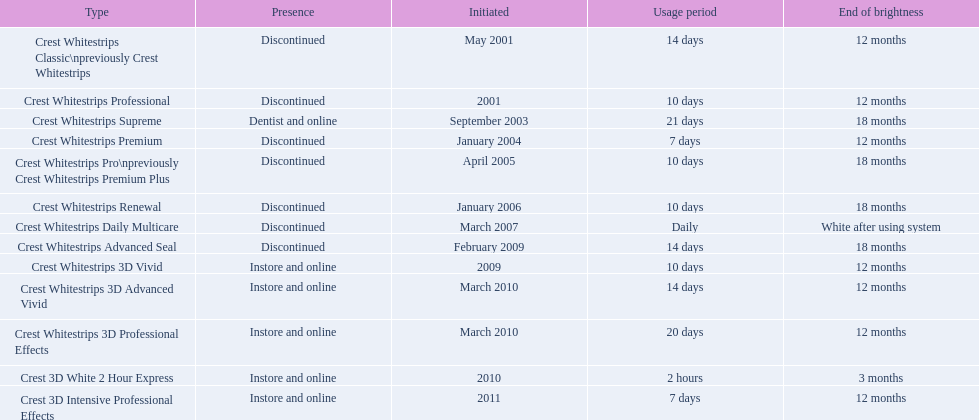Which of these products are discontinued? Crest Whitestrips Classic\npreviously Crest Whitestrips, Crest Whitestrips Professional, Crest Whitestrips Premium, Crest Whitestrips Pro\npreviously Crest Whitestrips Premium Plus, Crest Whitestrips Renewal, Crest Whitestrips Daily Multicare, Crest Whitestrips Advanced Seal. Which of these products have a 14 day length of use? Crest Whitestrips Classic\npreviously Crest Whitestrips, Crest Whitestrips Advanced Seal. Which of these products was introduced in 2009? Crest Whitestrips Advanced Seal. 